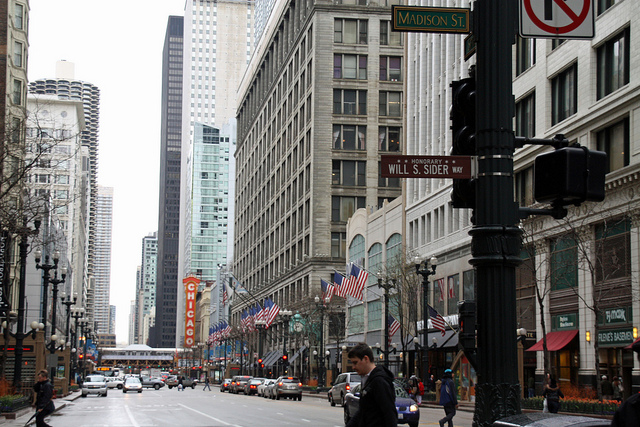<image>Why are there two lights? It is unknown why there are two lights. They might be for traffic or to light the street. Why are there two lights? I don't know why there are two lights. It can be for different purposes such as lighting the street, visibility, or traffic control. 